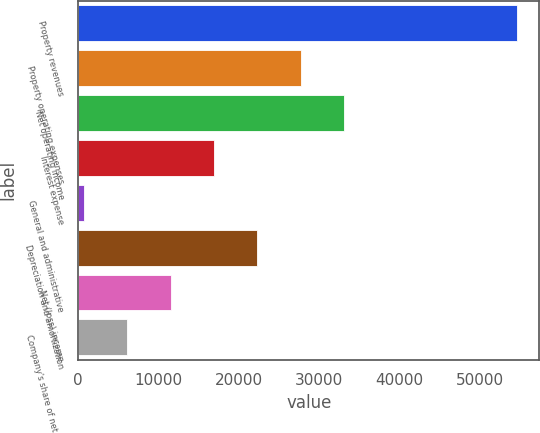Convert chart. <chart><loc_0><loc_0><loc_500><loc_500><bar_chart><fcel>Property revenues<fcel>Property operating expenses<fcel>Net operating income<fcel>Interest expense<fcel>General and administrative<fcel>Depreciation and amortization<fcel>Net (loss) income<fcel>Company's share of net (loss)<nl><fcel>54699<fcel>27704<fcel>33103<fcel>16906<fcel>709<fcel>22305<fcel>11507<fcel>6108<nl></chart> 